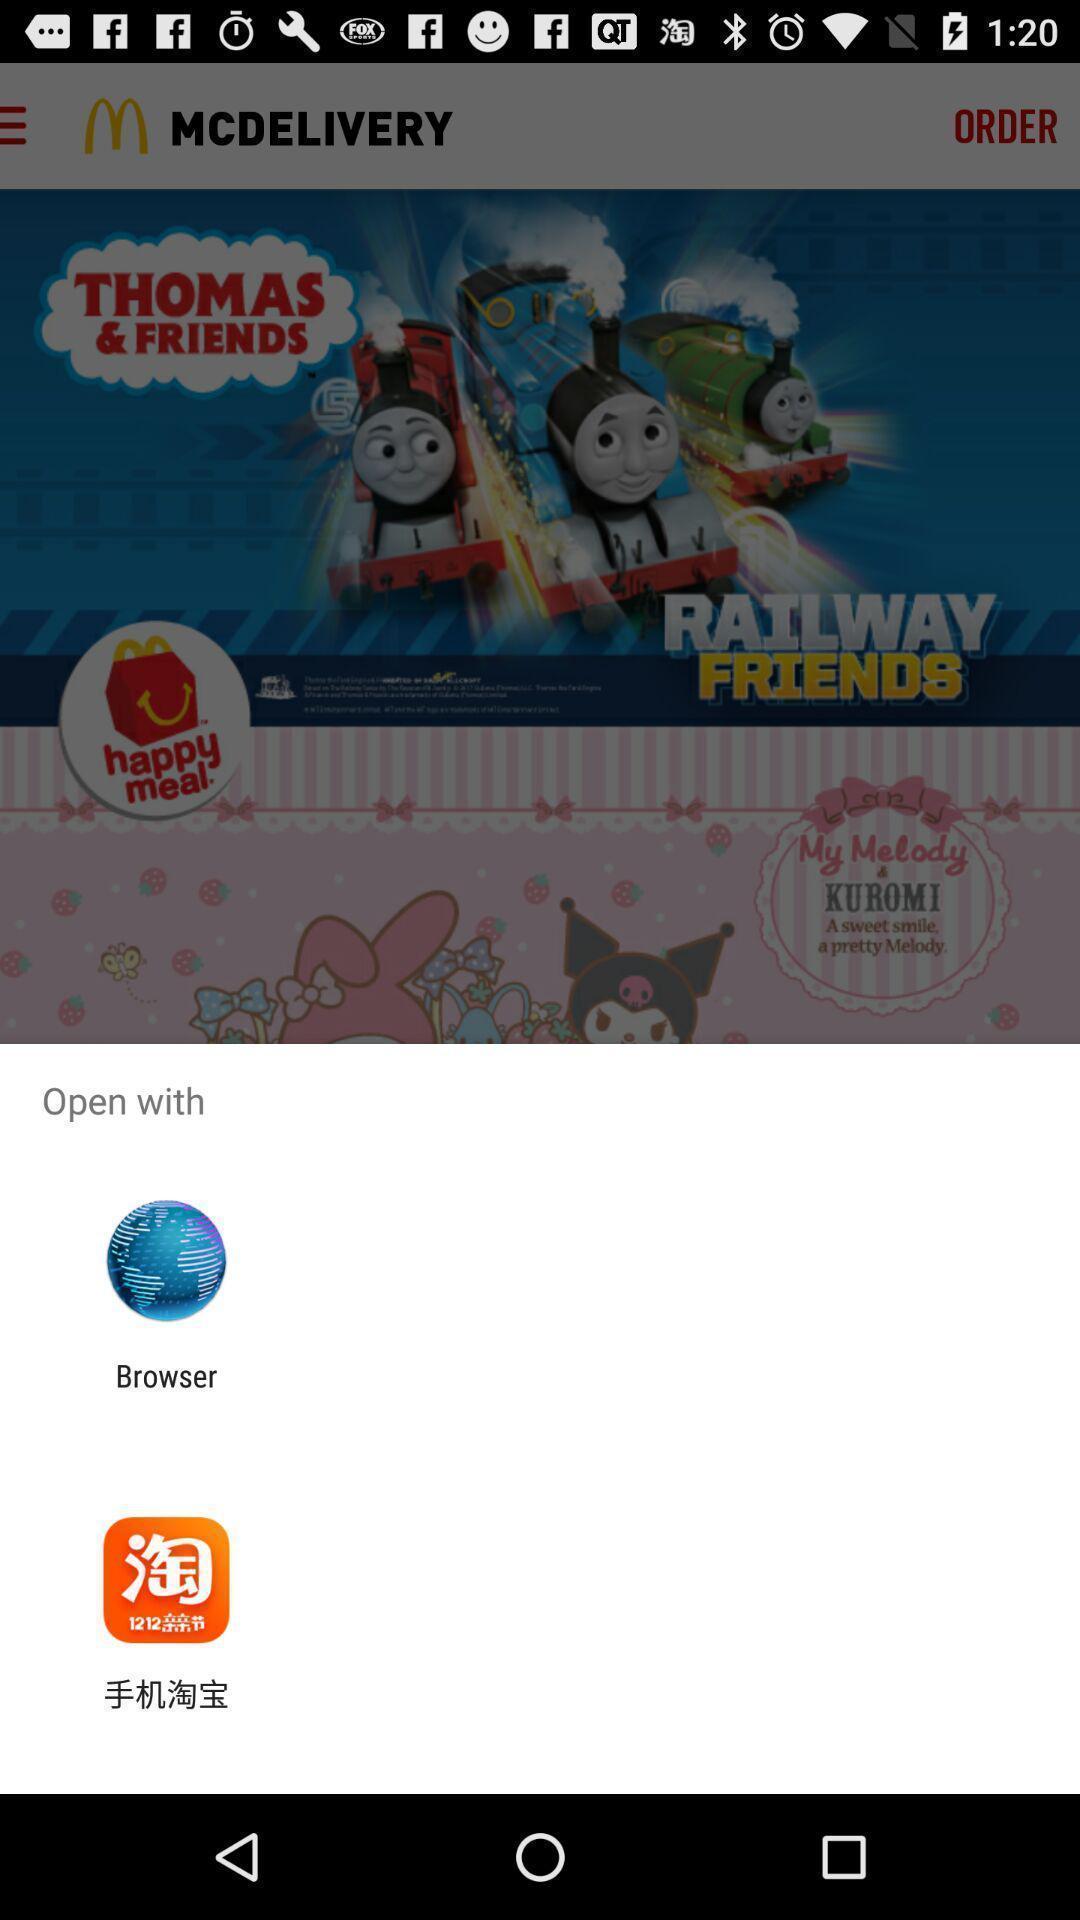Summarize the main components in this picture. Pop-up displaying to open an app. 